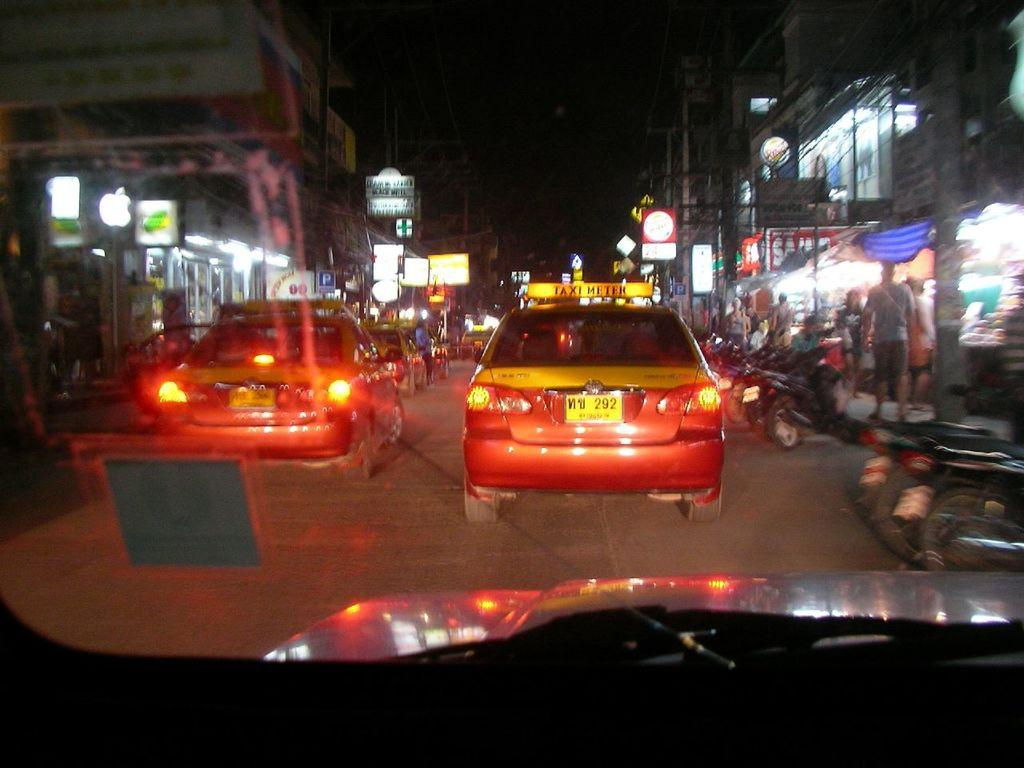Provide a one-sentence caption for the provided image. The red car visible has a yellow sign on the roof saying Taxi meter. 